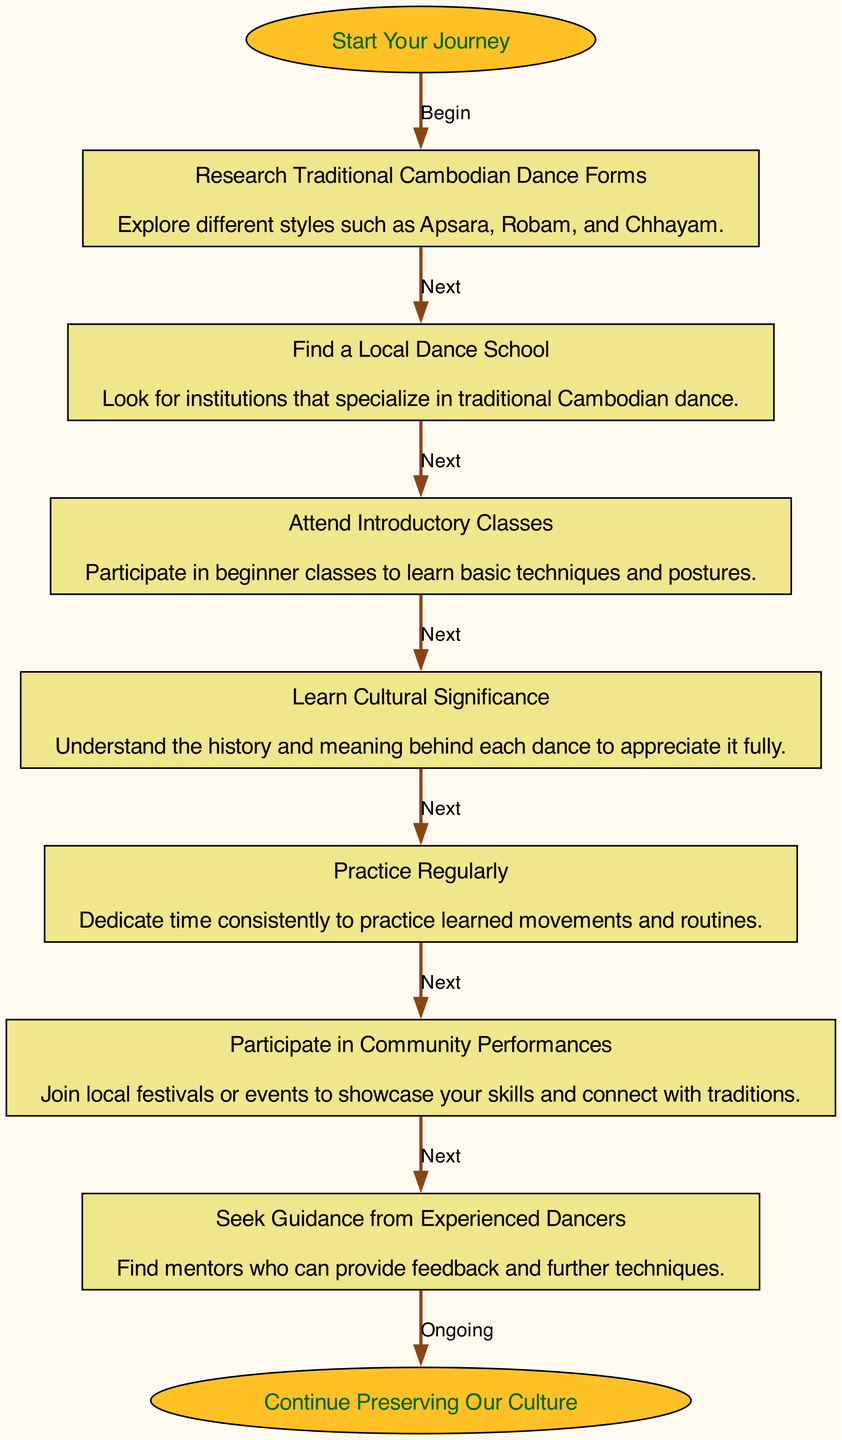What is the first step in learning traditional Cambodian dance? The first step is indicated by the "Start Your Journey" node, which connects to the first process node for researching traditional dance forms. The diagram flows from this starting point directly into the first step.
Answer: Research Traditional Cambodian Dance Forms How many steps are there in the diagram? By counting the nodes representing each step in the learning process, we find a total of seven steps listed after the starting point.
Answer: 7 What is the last step in the diagram? The last step is the conclusion of the flow, leading to the "Continue Preserving Our Culture" node, which connects from the last step focused on community performances.
Answer: Participate in Community Performances Which step comes after "Learn Cultural Significance"? To determine the order, we can observe the flow chart's connections. "Learn Cultural Significance" is followed by a direct connection to "Practice Regularly."
Answer: Practice Regularly What color is the starting point node? The starting point node is specifically designed with a goldenrod1 fill color. This distinct coloration sets it apart from the steps which are khaki in color.
Answer: Goldenrod1 How is the relationship between "Find a Local Dance School" and "Attend Introductory Classes"? The diagram shows a sequential connection between these two steps, indicating that once you find a local dance school, the logical next action is to attend introductory classes specifically provided there.
Answer: Next Which step emphasizes the importance of mentorship? The diagram highlights the need for guidance through the step named "Seek Guidance from Experienced Dancers," which stresses finding mentors in this dance learning journey.
Answer: Seek Guidance from Experienced Dancers What action should you take if you want to showcase your skills? The diagram indicates that to showcase your skills, you should participate in community performances, making this a vital action in the learning flow.
Answer: Participate in Community Performances 